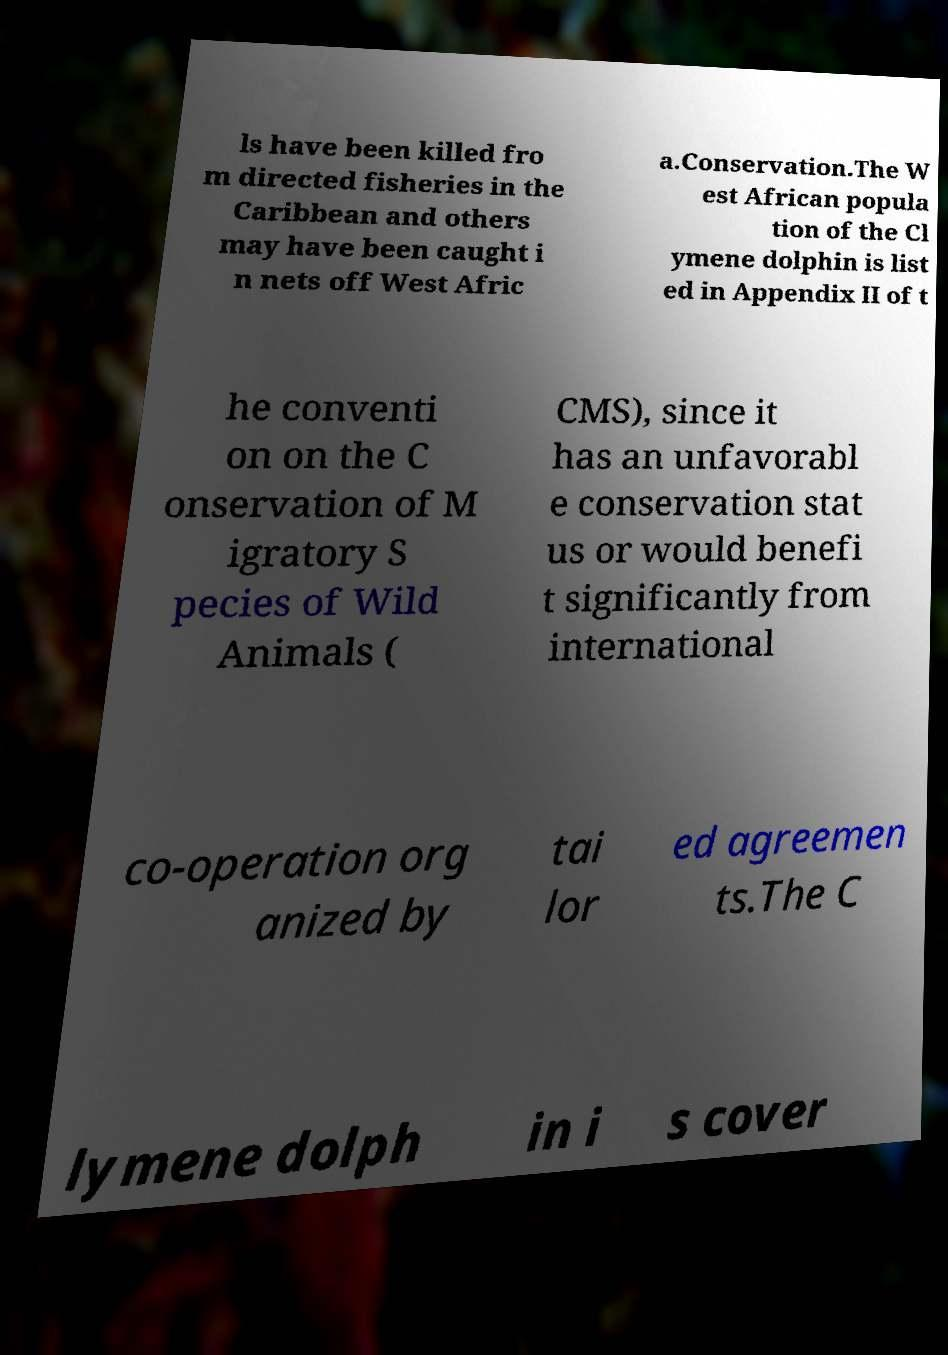For documentation purposes, I need the text within this image transcribed. Could you provide that? ls have been killed fro m directed fisheries in the Caribbean and others may have been caught i n nets off West Afric a.Conservation.The W est African popula tion of the Cl ymene dolphin is list ed in Appendix II of t he conventi on on the C onservation of M igratory S pecies of Wild Animals ( CMS), since it has an unfavorabl e conservation stat us or would benefi t significantly from international co-operation org anized by tai lor ed agreemen ts.The C lymene dolph in i s cover 